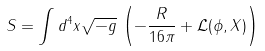<formula> <loc_0><loc_0><loc_500><loc_500>S = \int d ^ { 4 } x \sqrt { - g } \, \left ( - \frac { R } { 1 6 \pi } + \mathcal { L } ( \phi , X ) \right )</formula> 